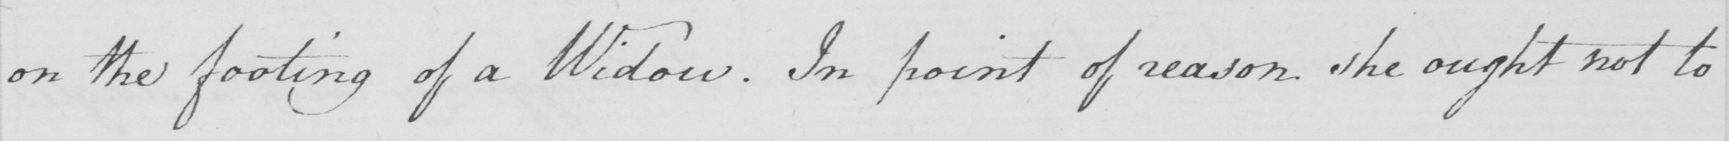What is written in this line of handwriting? on the footing of a Widow . In point of reason she ought not to 